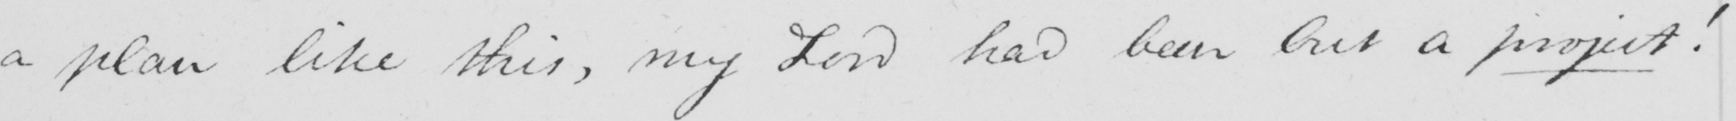What text is written in this handwritten line? a plan like this , my Lord had been but a project ! 